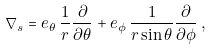Convert formula to latex. <formula><loc_0><loc_0><loc_500><loc_500>\nabla _ { s } = e _ { \theta } \, \frac { 1 } { r } \frac { \partial } { \partial \theta } + e _ { \phi } \, \frac { 1 } { r \sin \theta } \frac { \partial } { \partial \phi } \, ,</formula> 